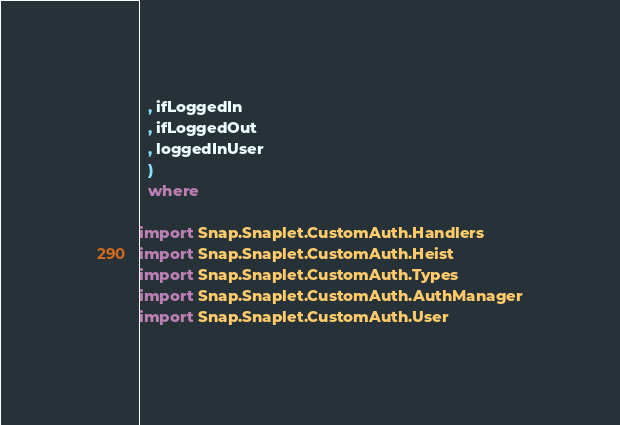<code> <loc_0><loc_0><loc_500><loc_500><_Haskell_>  , ifLoggedIn
  , ifLoggedOut
  , loggedInUser
  )
  where

import Snap.Snaplet.CustomAuth.Handlers
import Snap.Snaplet.CustomAuth.Heist
import Snap.Snaplet.CustomAuth.Types
import Snap.Snaplet.CustomAuth.AuthManager
import Snap.Snaplet.CustomAuth.User
</code> 